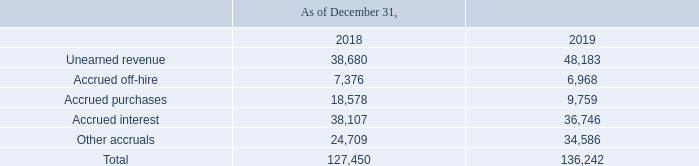GasLog Ltd. and its Subsidiaries
Notes to the consolidated financial statements (Continued)
For the years ended December 31, 2017, 2018 and 2019
(All amounts expressed in thousands of U.S. Dollars, except share and per share data)
14. Other Payables and Accruals
An analysis of other payables and accruals is as follows:
The unearned revenue represents charter hires received in advance in December 2019 relating to the hire period of January 2020 for 22 vessels (December 2018: 17 vessels).
What does unearned revenue represent for 2019? The unearned revenue represents charter hires received in advance in december 2019 relating to the hire period of january 2020 for 22 vessels. In which years was the other payables and accruals recorded for? 2018, 2019. How many vessels were hired in 2018? 17 vessels. In which year was the accrued interest higher? 38,107 > 36,746
Answer: 2018. What was the change in accrued purchases from 2018 to 2019?
Answer scale should be: thousand. 9,759 - 18,578 
Answer: -8819. What was the percentage change in total payables and  accruals from 2018 to 2019?
Answer scale should be: percent. (136,242 - 127,450)/127,450 
Answer: 6.9. 